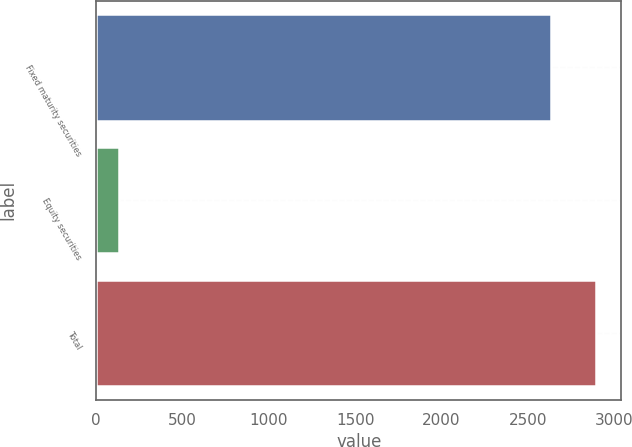Convert chart. <chart><loc_0><loc_0><loc_500><loc_500><bar_chart><fcel>Fixed maturity securities<fcel>Equity securities<fcel>Total<nl><fcel>2634<fcel>130<fcel>2897.4<nl></chart> 